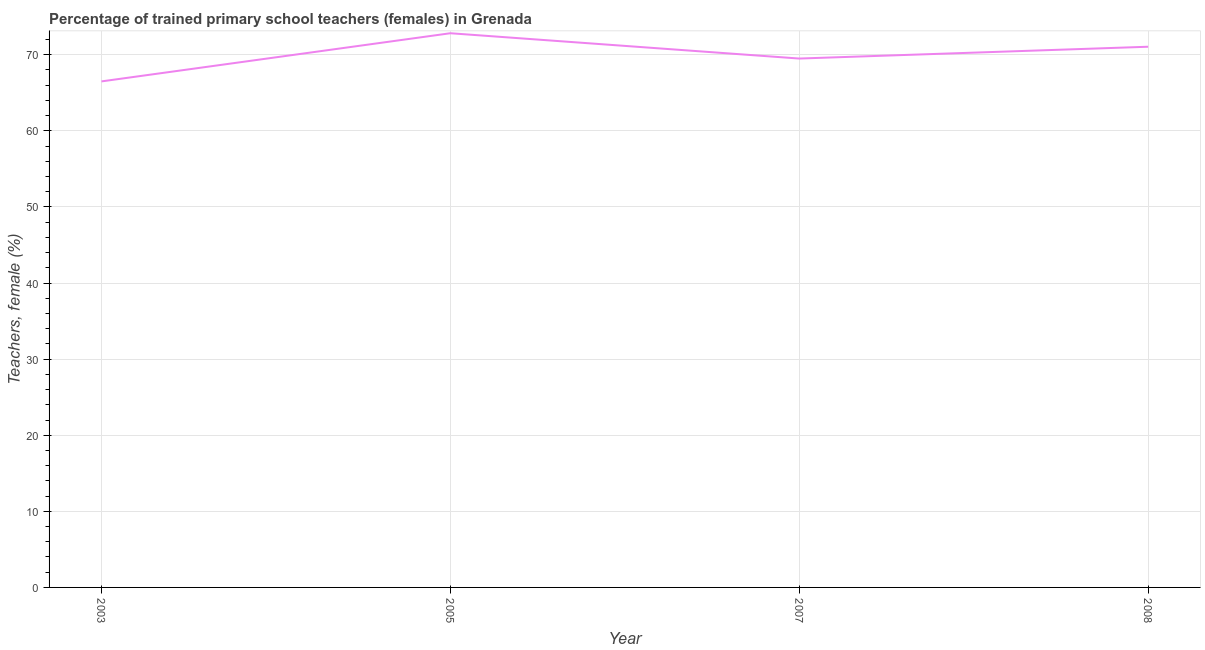What is the percentage of trained female teachers in 2007?
Your answer should be compact. 69.5. Across all years, what is the maximum percentage of trained female teachers?
Provide a succinct answer. 72.83. Across all years, what is the minimum percentage of trained female teachers?
Your answer should be compact. 66.5. In which year was the percentage of trained female teachers maximum?
Give a very brief answer. 2005. What is the sum of the percentage of trained female teachers?
Provide a succinct answer. 279.88. What is the difference between the percentage of trained female teachers in 2005 and 2007?
Your answer should be compact. 3.33. What is the average percentage of trained female teachers per year?
Give a very brief answer. 69.97. What is the median percentage of trained female teachers?
Ensure brevity in your answer.  70.28. In how many years, is the percentage of trained female teachers greater than 38 %?
Keep it short and to the point. 4. What is the ratio of the percentage of trained female teachers in 2007 to that in 2008?
Make the answer very short. 0.98. Is the percentage of trained female teachers in 2005 less than that in 2008?
Your answer should be compact. No. Is the difference between the percentage of trained female teachers in 2005 and 2008 greater than the difference between any two years?
Your answer should be compact. No. What is the difference between the highest and the second highest percentage of trained female teachers?
Your answer should be compact. 1.77. What is the difference between the highest and the lowest percentage of trained female teachers?
Keep it short and to the point. 6.33. Does the percentage of trained female teachers monotonically increase over the years?
Your answer should be very brief. No. How many lines are there?
Provide a succinct answer. 1. How many years are there in the graph?
Ensure brevity in your answer.  4. Does the graph contain any zero values?
Your answer should be very brief. No. Does the graph contain grids?
Make the answer very short. Yes. What is the title of the graph?
Provide a succinct answer. Percentage of trained primary school teachers (females) in Grenada. What is the label or title of the Y-axis?
Ensure brevity in your answer.  Teachers, female (%). What is the Teachers, female (%) of 2003?
Ensure brevity in your answer.  66.5. What is the Teachers, female (%) in 2005?
Make the answer very short. 72.83. What is the Teachers, female (%) in 2007?
Ensure brevity in your answer.  69.5. What is the Teachers, female (%) in 2008?
Offer a terse response. 71.05. What is the difference between the Teachers, female (%) in 2003 and 2005?
Ensure brevity in your answer.  -6.33. What is the difference between the Teachers, female (%) in 2003 and 2007?
Your response must be concise. -3. What is the difference between the Teachers, female (%) in 2003 and 2008?
Keep it short and to the point. -4.56. What is the difference between the Teachers, female (%) in 2005 and 2007?
Provide a short and direct response. 3.33. What is the difference between the Teachers, female (%) in 2005 and 2008?
Provide a succinct answer. 1.77. What is the difference between the Teachers, female (%) in 2007 and 2008?
Provide a succinct answer. -1.55. What is the ratio of the Teachers, female (%) in 2003 to that in 2005?
Your response must be concise. 0.91. What is the ratio of the Teachers, female (%) in 2003 to that in 2008?
Provide a succinct answer. 0.94. What is the ratio of the Teachers, female (%) in 2005 to that in 2007?
Offer a very short reply. 1.05. What is the ratio of the Teachers, female (%) in 2007 to that in 2008?
Provide a short and direct response. 0.98. 